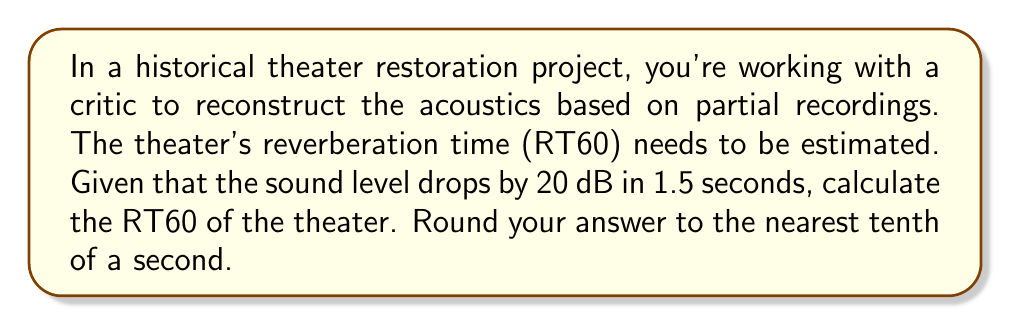Help me with this question. To solve this problem, we'll use the concept of reverberation time (RT60), which is the time it takes for sound to decay by 60 dB. We'll follow these steps:

1. Understand the given information:
   - Sound level drops by 20 dB in 1.5 seconds

2. Set up the proportion:
   $\frac{20 \text{ dB}}{1.5 \text{ s}} = \frac{60 \text{ dB}}{x \text{ s}}$

3. Cross multiply:
   $20x = 60 \cdot 1.5$

4. Solve for $x$:
   $x = \frac{60 \cdot 1.5}{20} = \frac{90}{20} = 4.5$

5. Round to the nearest tenth:
   4.5 rounds to 4.5

Therefore, the RT60 of the theater is 4.5 seconds.
Answer: 4.5 seconds 